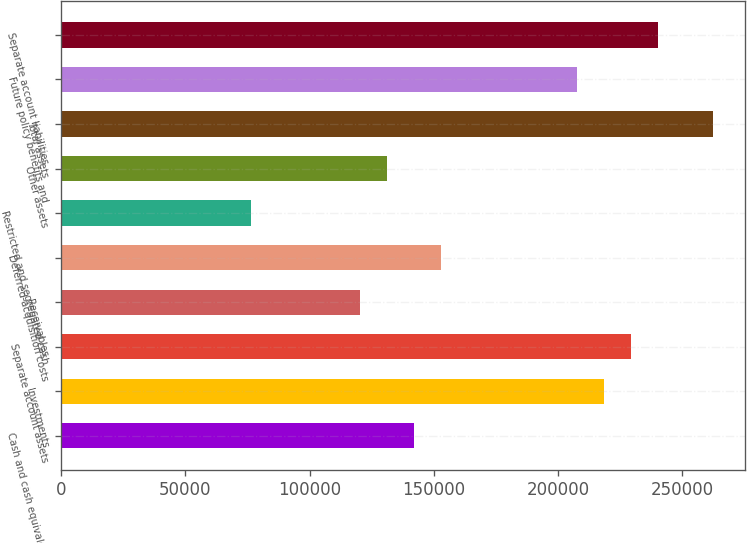Convert chart. <chart><loc_0><loc_0><loc_500><loc_500><bar_chart><fcel>Cash and cash equivalents<fcel>Investments<fcel>Separate account assets<fcel>Receivables<fcel>Deferred acquisition costs<fcel>Restricted and segregated cash<fcel>Other assets<fcel>Total assets<fcel>Future policy benefits and<fcel>Separate account liabilities<nl><fcel>141998<fcel>218457<fcel>229380<fcel>120153<fcel>152921<fcel>76461.9<fcel>131075<fcel>262148<fcel>207534<fcel>240302<nl></chart> 